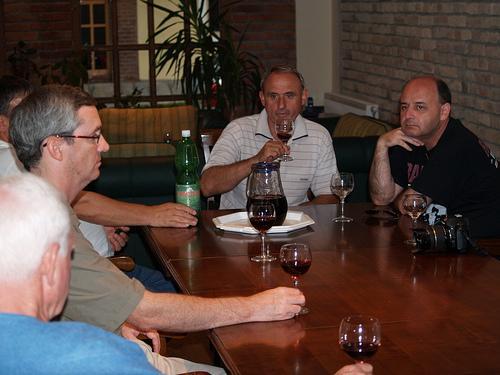What can happen if too much of this liquid is ingested? Please explain your reasoning. sickness. The kidneys can't work fast enough to remove excess liquid and can cause nausea, diarrhea and vomiting. 